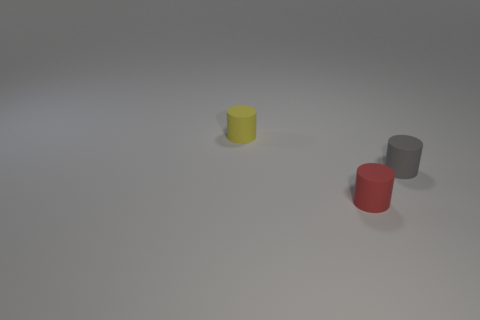What color is the rubber cylinder that is behind the small cylinder that is right of the small red thing?
Your answer should be compact. Yellow. Are there any tiny things?
Your response must be concise. Yes. What is the color of the tiny thing that is to the right of the tiny yellow matte cylinder and left of the tiny gray object?
Offer a terse response. Red. There is a rubber object in front of the tiny gray cylinder; is it the same size as the object that is left of the red cylinder?
Your answer should be very brief. Yes. How many other objects are there of the same size as the gray object?
Your response must be concise. 2. There is a tiny cylinder on the right side of the red cylinder; how many tiny objects are to the left of it?
Offer a very short reply. 2. Are there fewer small rubber things behind the red object than red matte cylinders?
Make the answer very short. No. The small thing that is behind the matte cylinder on the right side of the rubber object that is in front of the tiny gray rubber thing is what shape?
Keep it short and to the point. Cylinder. Do the gray matte thing and the tiny yellow object have the same shape?
Offer a terse response. Yes. How many other things are the same shape as the gray object?
Provide a short and direct response. 2. 